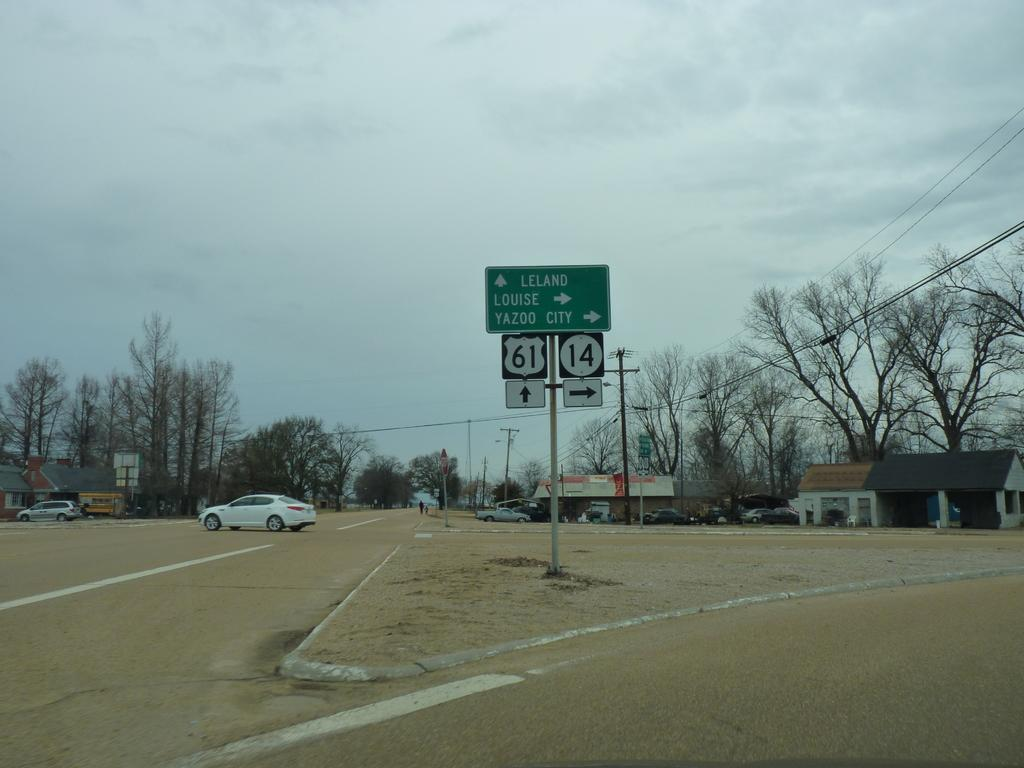<image>
Render a clear and concise summary of the photo. the numbers 61 and 14 on a sign 